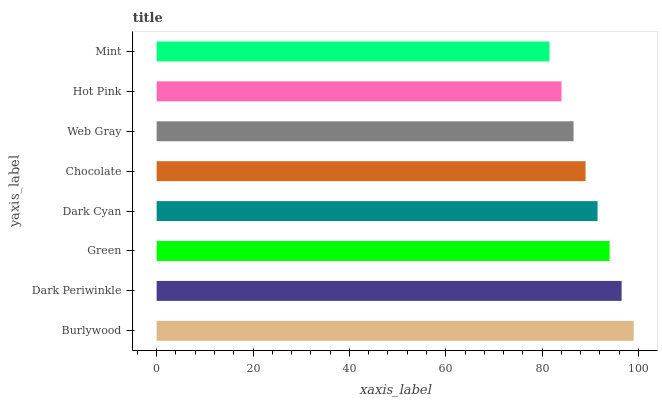Is Mint the minimum?
Answer yes or no. Yes. Is Burlywood the maximum?
Answer yes or no. Yes. Is Dark Periwinkle the minimum?
Answer yes or no. No. Is Dark Periwinkle the maximum?
Answer yes or no. No. Is Burlywood greater than Dark Periwinkle?
Answer yes or no. Yes. Is Dark Periwinkle less than Burlywood?
Answer yes or no. Yes. Is Dark Periwinkle greater than Burlywood?
Answer yes or no. No. Is Burlywood less than Dark Periwinkle?
Answer yes or no. No. Is Dark Cyan the high median?
Answer yes or no. Yes. Is Chocolate the low median?
Answer yes or no. Yes. Is Mint the high median?
Answer yes or no. No. Is Mint the low median?
Answer yes or no. No. 